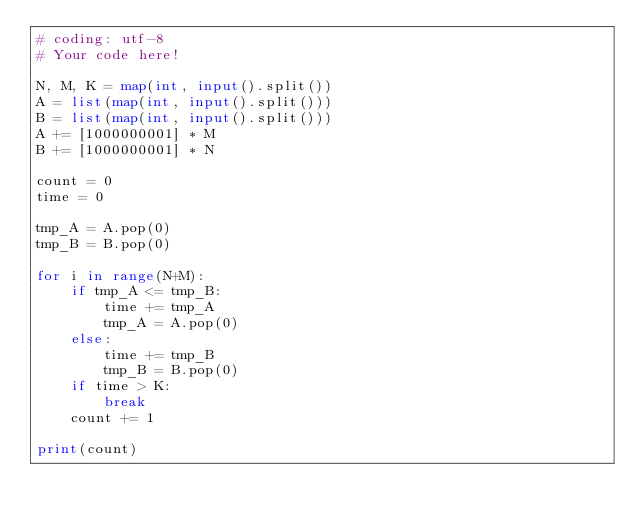Convert code to text. <code><loc_0><loc_0><loc_500><loc_500><_Python_># coding: utf-8
# Your code here!

N, M, K = map(int, input().split())
A = list(map(int, input().split()))
B = list(map(int, input().split()))
A += [1000000001] * M
B += [1000000001] * N

count = 0
time = 0

tmp_A = A.pop(0)
tmp_B = B.pop(0)

for i in range(N+M):
    if tmp_A <= tmp_B:
        time += tmp_A
        tmp_A = A.pop(0)
    else:
        time += tmp_B 
        tmp_B = B.pop(0)
    if time > K:
        break
    count += 1
    
print(count)</code> 